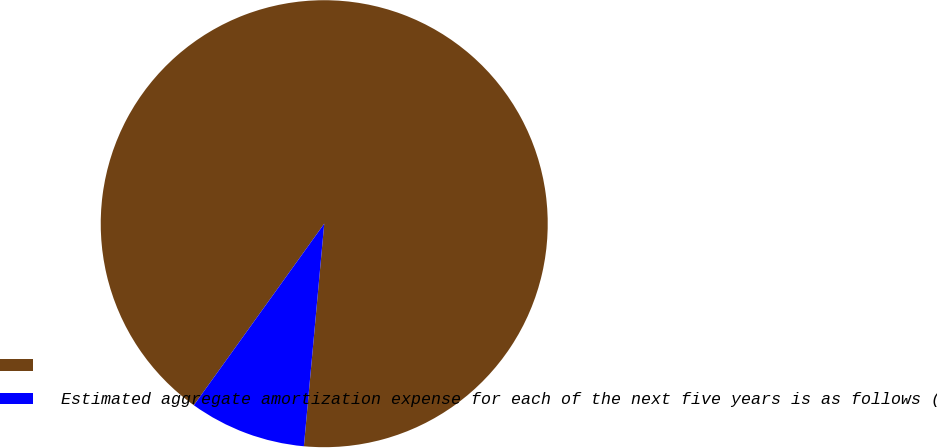Convert chart. <chart><loc_0><loc_0><loc_500><loc_500><pie_chart><ecel><fcel>Estimated aggregate amortization expense for each of the next five years is as follows (in millions):<nl><fcel>91.54%<fcel>8.46%<nl></chart> 